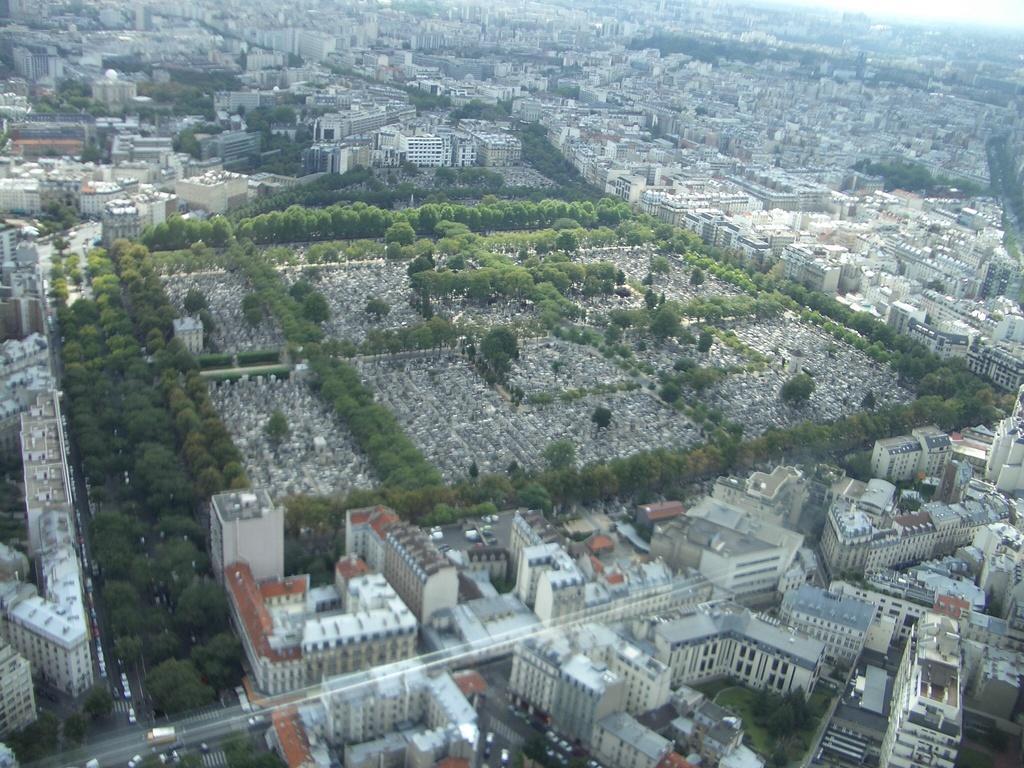How would you summarize this image in a sentence or two? This is an aerial view of an image where we can see many buildings, trees and we can see vehicles moving on the road. 